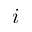Convert formula to latex. <formula><loc_0><loc_0><loc_500><loc_500>i</formula> 